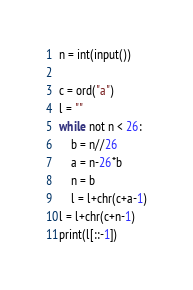<code> <loc_0><loc_0><loc_500><loc_500><_Python_>n = int(input())

c = ord("a")
l = ""
while not n < 26:
    b = n//26
    a = n-26*b
    n = b
    l = l+chr(c+a-1)
l = l+chr(c+n-1)
print(l[::-1])
</code> 